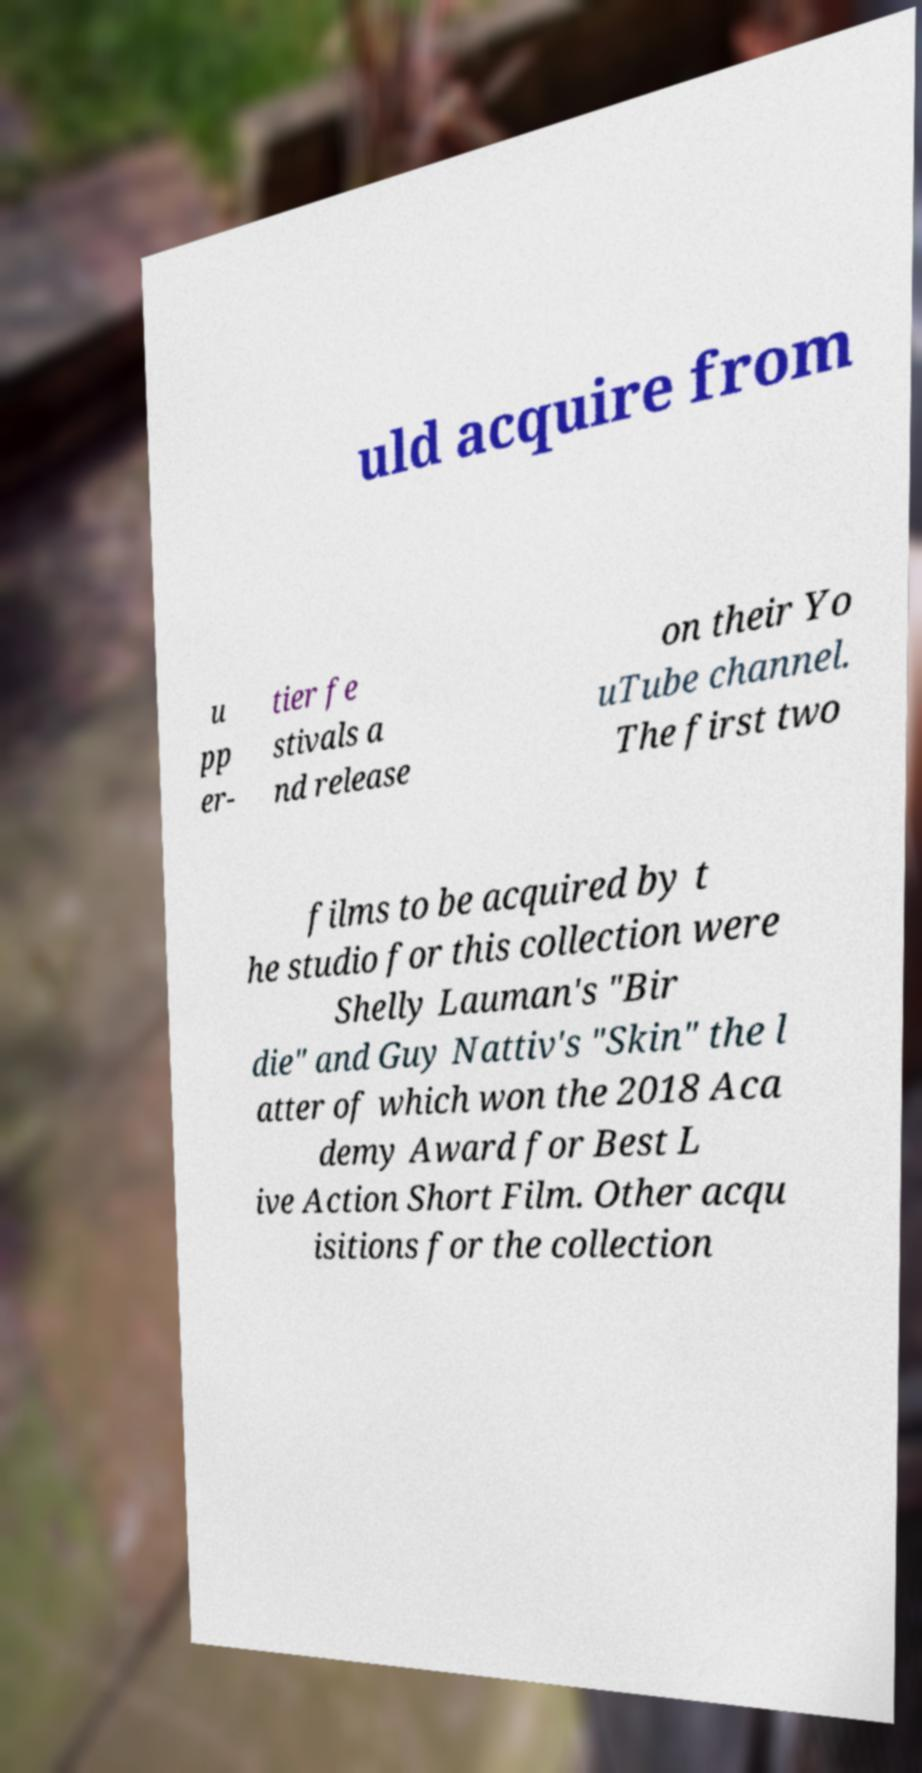Can you read and provide the text displayed in the image?This photo seems to have some interesting text. Can you extract and type it out for me? uld acquire from u pp er- tier fe stivals a nd release on their Yo uTube channel. The first two films to be acquired by t he studio for this collection were Shelly Lauman's "Bir die" and Guy Nattiv's "Skin" the l atter of which won the 2018 Aca demy Award for Best L ive Action Short Film. Other acqu isitions for the collection 